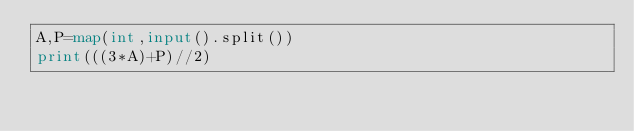<code> <loc_0><loc_0><loc_500><loc_500><_Python_>A,P=map(int,input().split())
print(((3*A)+P)//2)</code> 